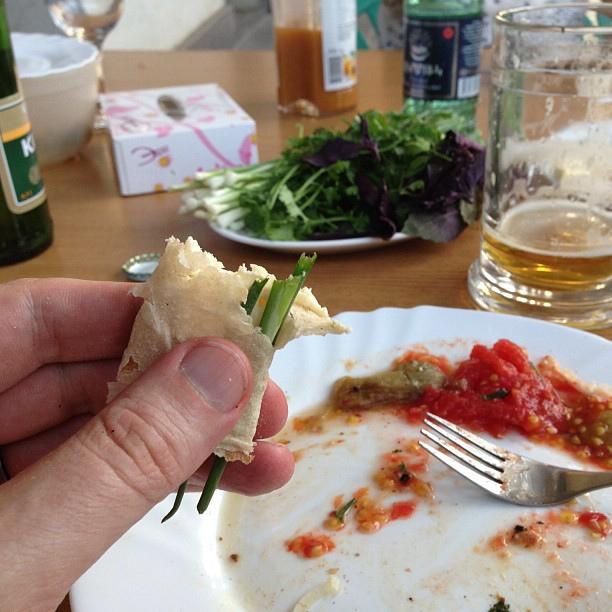How many prongs are on the fork?
Give a very brief answer. 4. Is the meal almost finished?
Be succinct. Yes. What is in the glass?
Concise answer only. Beer. 